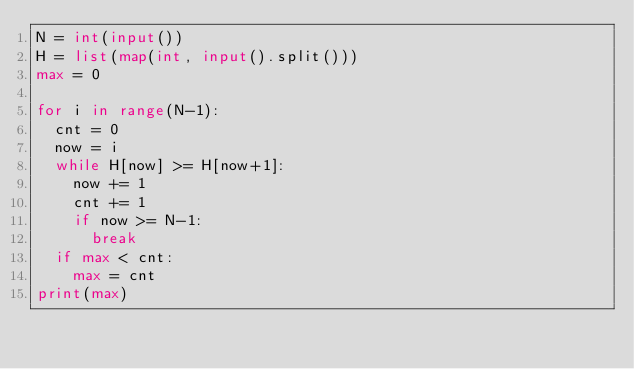Convert code to text. <code><loc_0><loc_0><loc_500><loc_500><_Python_>N = int(input())
H = list(map(int, input().split()))
max = 0
 
for i in range(N-1):
  cnt = 0
  now = i
  while H[now] >= H[now+1]:
    now += 1
    cnt += 1
    if now >= N-1:
      break
  if max < cnt:
    max = cnt
print(max)</code> 